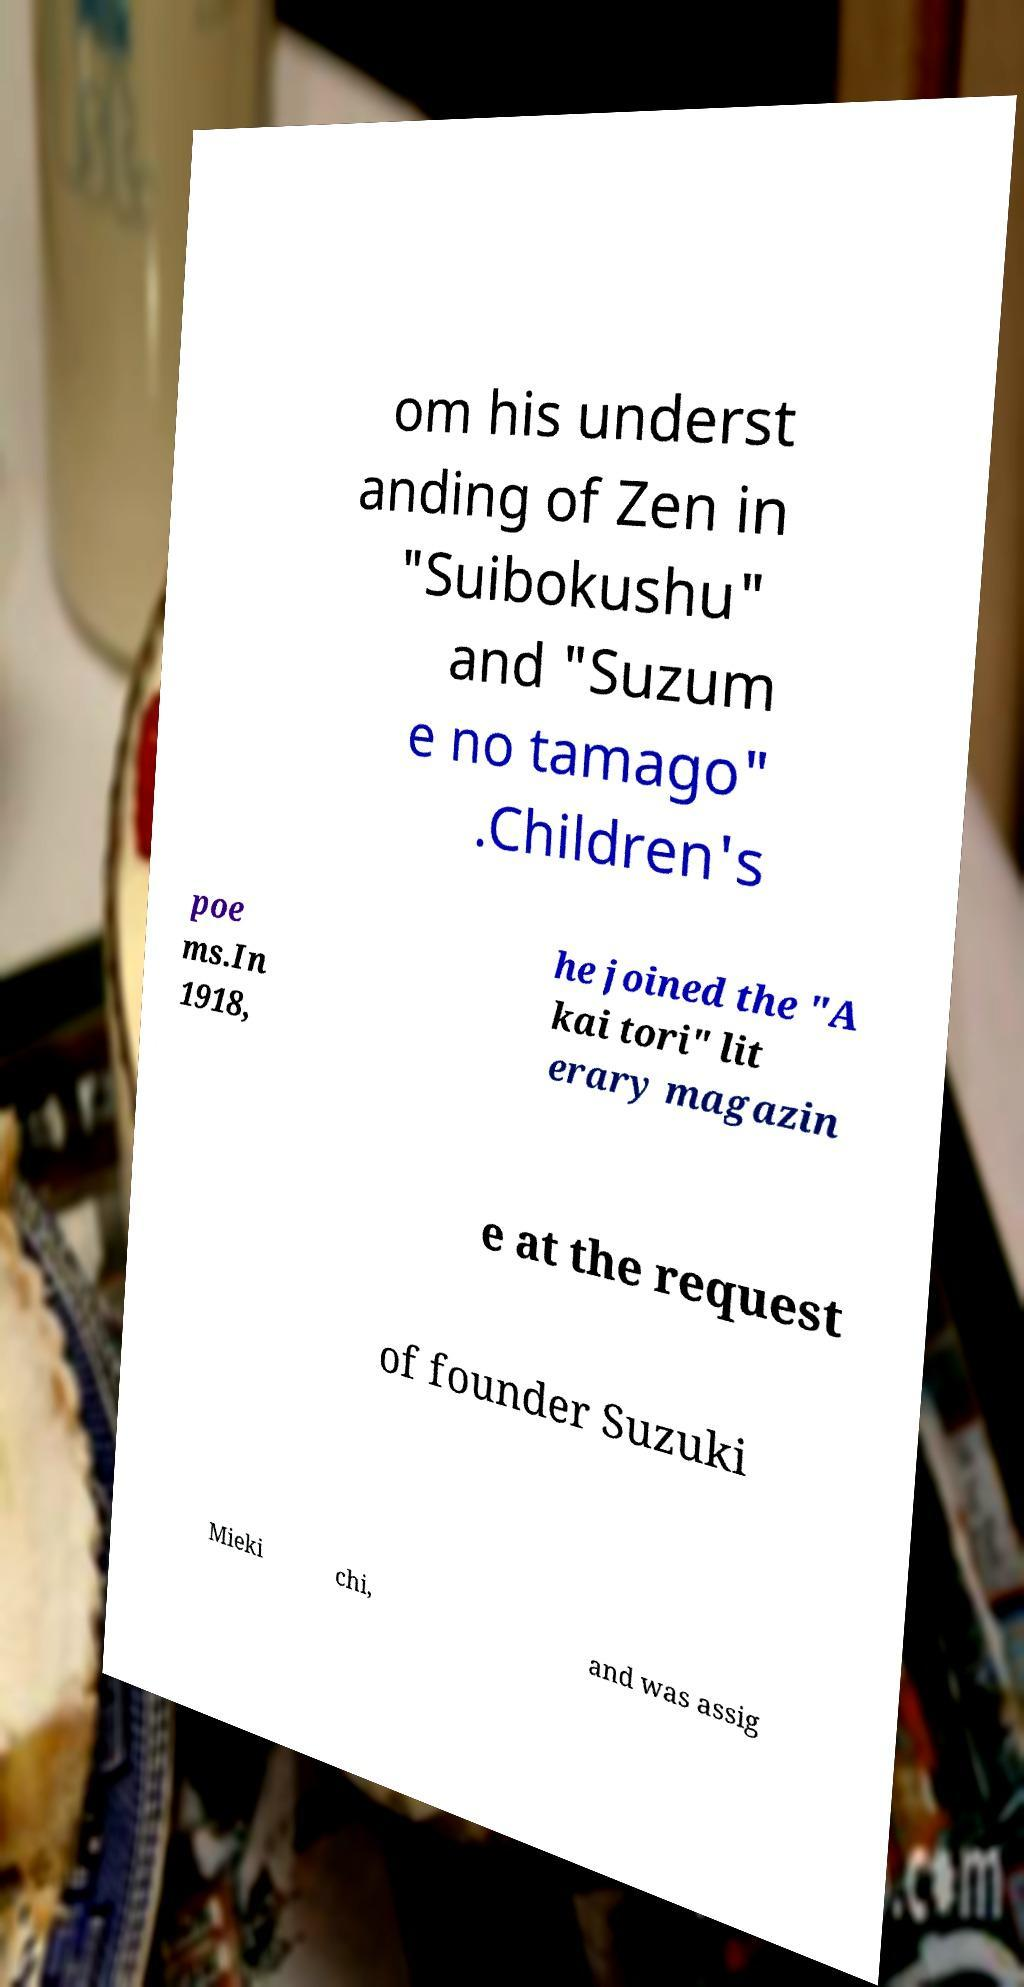There's text embedded in this image that I need extracted. Can you transcribe it verbatim? om his underst anding of Zen in "Suibokushu" and "Suzum e no tamago" .Children's poe ms.In 1918, he joined the "A kai tori" lit erary magazin e at the request of founder Suzuki Mieki chi, and was assig 